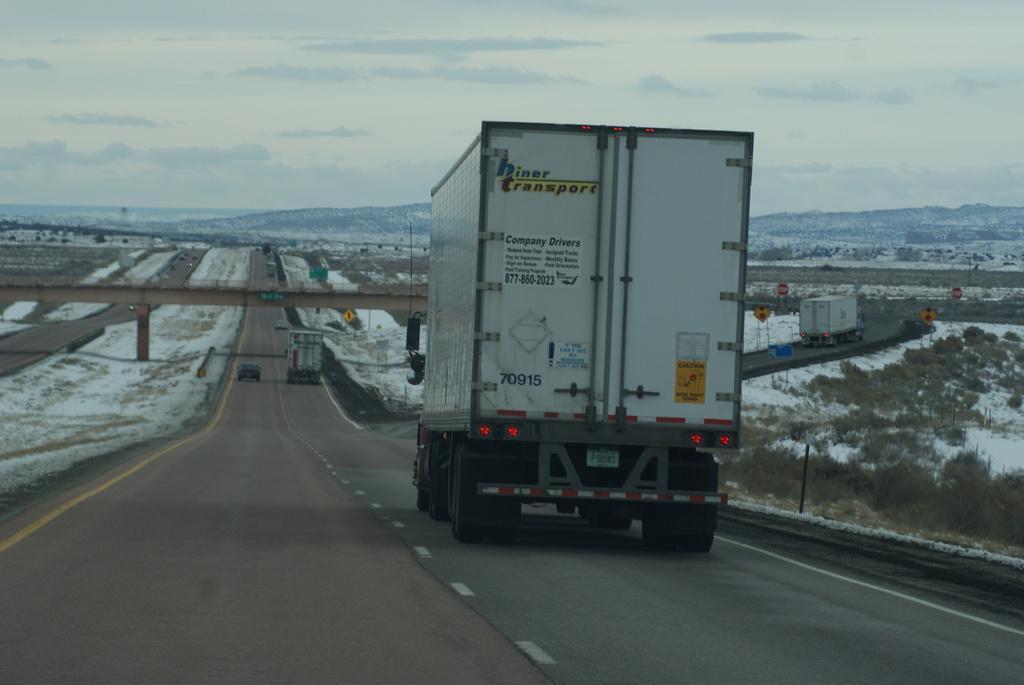Can you describe this image briefly? In the center of the image we can see trucks and cars on the road. There is a bridge. In the background there are hills and sky. We can see boards. 